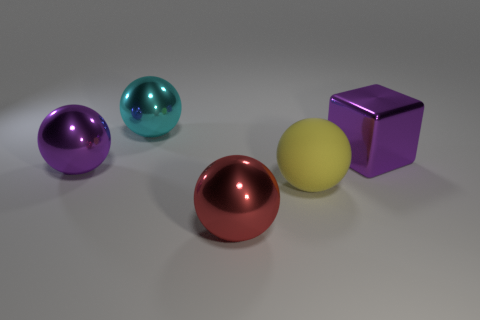Subtract all gray balls. Subtract all red cubes. How many balls are left? 4 Add 5 large yellow rubber balls. How many objects exist? 10 Subtract all spheres. How many objects are left? 1 Subtract 0 yellow cylinders. How many objects are left? 5 Subtract all red shiny things. Subtract all large cyan metal objects. How many objects are left? 3 Add 5 purple blocks. How many purple blocks are left? 6 Add 3 matte blocks. How many matte blocks exist? 3 